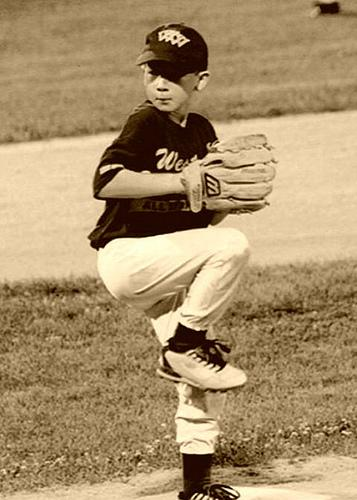Question: who is in the picture?
Choices:
A. A boy.
B. A girl.
C. A mother.
D. A sister.
Answer with the letter. Answer: A Question: how is he throwing?
Choices:
A. Very far.
B. With his right arm.
C. With both hands.
D. With his left hand.
Answer with the letter. Answer: D Question: what is he wearing?
Choices:
A. A football uniform.
B. A soccer uniform.
C. A baseball uniform.
D. A hockey uniform.
Answer with the letter. Answer: C Question: where is he standing?
Choices:
A. On home base.
B. On third base.
C. In the bleachers.
D. On a pitcher's mound.
Answer with the letter. Answer: D Question: what is in the background?
Choices:
A. The scoreboard.
B. The outfield.
C. Other players.
D. Spectators.
Answer with the letter. Answer: B Question: what is he wearing on his right hand?
Choices:
A. A ring.
B. A glove.
C. Tape.
D. A bandage.
Answer with the letter. Answer: B Question: what surrounds the boy?
Choices:
A. Infield grass.
B. Other players.
C. The bases.
D. A fence.
Answer with the letter. Answer: A 